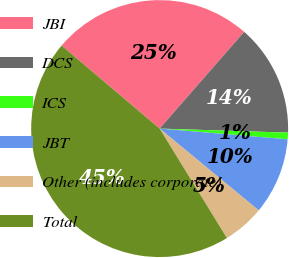<chart> <loc_0><loc_0><loc_500><loc_500><pie_chart><fcel>JBI<fcel>DCS<fcel>ICS<fcel>JBT<fcel>Other (includes corporate)<fcel>Total<nl><fcel>25.24%<fcel>14.07%<fcel>0.83%<fcel>9.66%<fcel>5.24%<fcel>44.95%<nl></chart> 